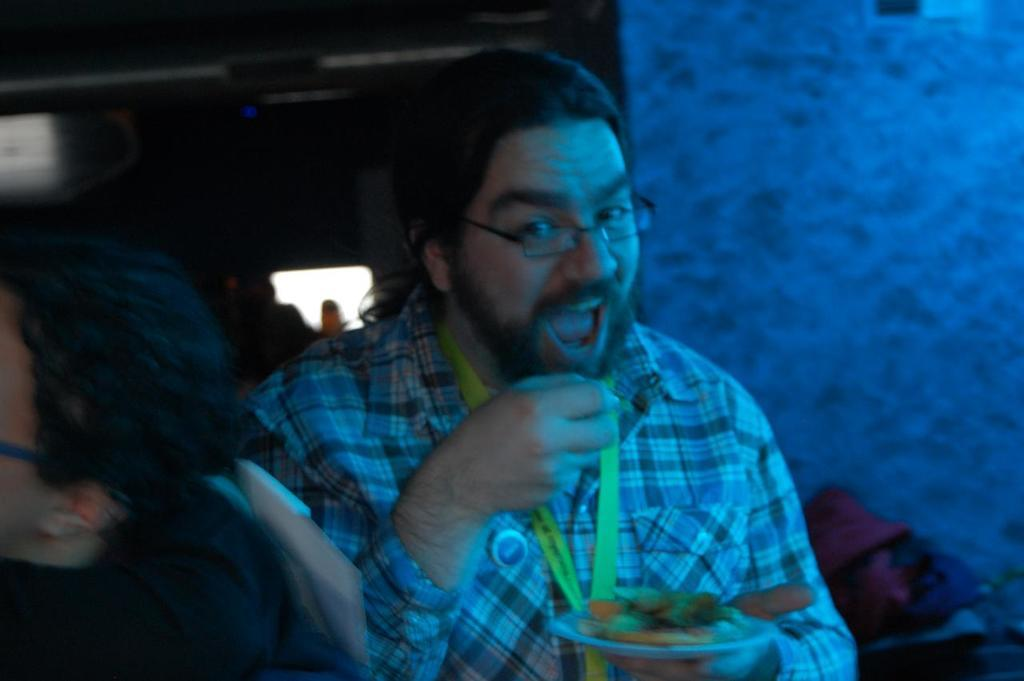Who is present in the image? There is a man in the image. What is the man holding in the image? The man is holding a plate of food. What is the man wearing in the image? The man is wearing a checked shirt. Can you describe the other person in the image? There is another person in the image, on the left side. What can be seen in the background of the image? There is a wall in the background of the image, along with other unspecified elements. What type of hat is the man wearing in the image? The man is not wearing a hat in the image. Can you describe the home where the man is located in the image? The image does not provide enough information to describe the home, as it only shows the man and the other person. 